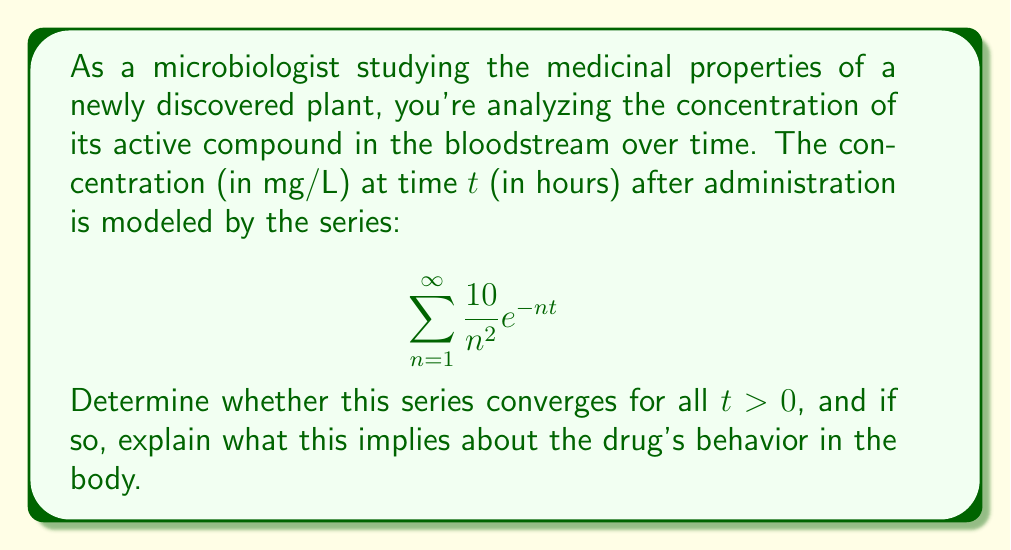Can you solve this math problem? Let's approach this step-by-step:

1) First, we need to check if the series converges for all t > 0. We can use the comparison test.

2) For any t > 0, we have $e^{-nt} < 1$ (since $e^{-nt}$ is always positive and less than 1 for positive n and t).

3) Therefore, for all t > 0:

   $$\frac{10}{n^2} e^{-nt} < \frac{10}{n^2}$$

4) Now, we can compare our series to the p-series $\sum_{n=1}^{\infty} \frac{10}{n^2}$.

5) We know that $\sum_{n=1}^{\infty} \frac{1}{n^2}$ converges (it's the famous Basel problem, with sum $\frac{\pi^2}{6}$).

6) Since our series is term-by-term less than or equal to a constant multiple of a convergent series, it must also converge for all t > 0.

7) The convergence of this series implies that the total amount of the drug in the bloodstream over all time is finite. This means:

   a) The drug concentration approaches zero as time increases.
   b) The body is able to eliminate the drug effectively.
   c) There's no risk of indefinite accumulation of the drug in the body.

8) Moreover, the series converges more rapidly for larger values of t, indicating faster elimination of the drug as time progresses.
Answer: The series converges for all t > 0, implying finite total drug exposure and effective elimination from the body. 